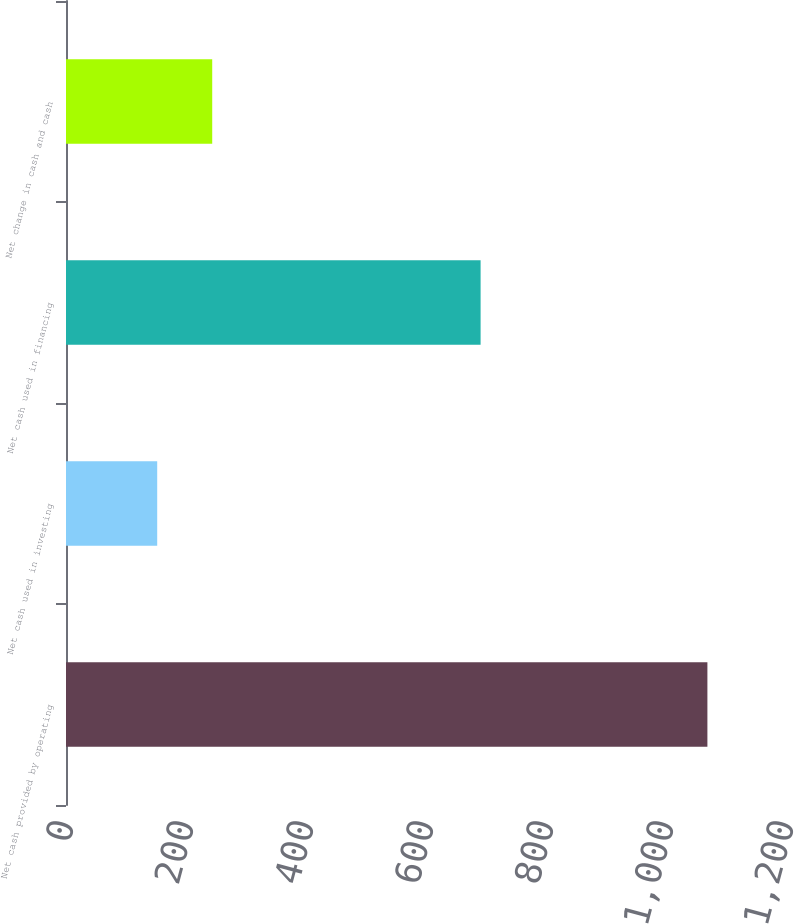Convert chart to OTSL. <chart><loc_0><loc_0><loc_500><loc_500><bar_chart><fcel>Net cash provided by operating<fcel>Net cash used in investing<fcel>Net cash used in financing<fcel>Net change in cash and cash<nl><fcel>1069<fcel>152<fcel>691<fcel>243.7<nl></chart> 